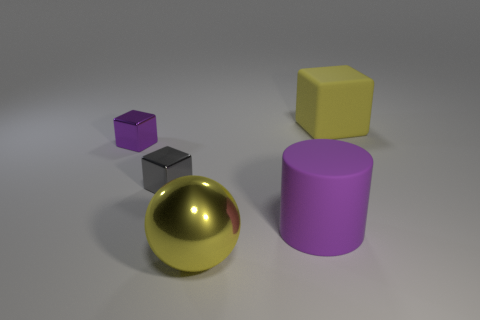Add 2 large red metallic blocks. How many objects exist? 7 Subtract all balls. How many objects are left? 4 Add 2 tiny blocks. How many tiny blocks are left? 4 Add 2 big cyan metallic balls. How many big cyan metallic balls exist? 2 Subtract 1 purple blocks. How many objects are left? 4 Subtract all large yellow rubber objects. Subtract all tiny gray metallic blocks. How many objects are left? 3 